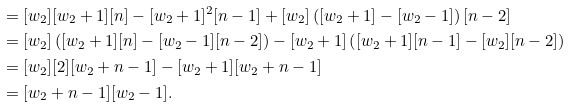<formula> <loc_0><loc_0><loc_500><loc_500>& = [ w _ { 2 } ] [ w _ { 2 } + 1 ] [ n ] - [ w _ { 2 } + 1 ] ^ { 2 } [ n - 1 ] + [ w _ { 2 } ] \left ( [ w _ { 2 } + 1 ] - [ w _ { 2 } - 1 ] \right ) [ n - 2 ] \\ & = [ w _ { 2 } ] \left ( [ w _ { 2 } + 1 ] [ n ] - [ w _ { 2 } - 1 ] [ n - 2 ] \right ) - [ w _ { 2 } + 1 ] \left ( [ w _ { 2 } + 1 ] [ n - 1 ] - [ w _ { 2 } ] [ n - 2 ] \right ) \\ & = [ w _ { 2 } ] [ 2 ] [ w _ { 2 } + n - 1 ] - [ w _ { 2 } + 1 ] [ w _ { 2 } + n - 1 ] \\ & = [ w _ { 2 } + n - 1 ] [ w _ { 2 } - 1 ] .</formula> 